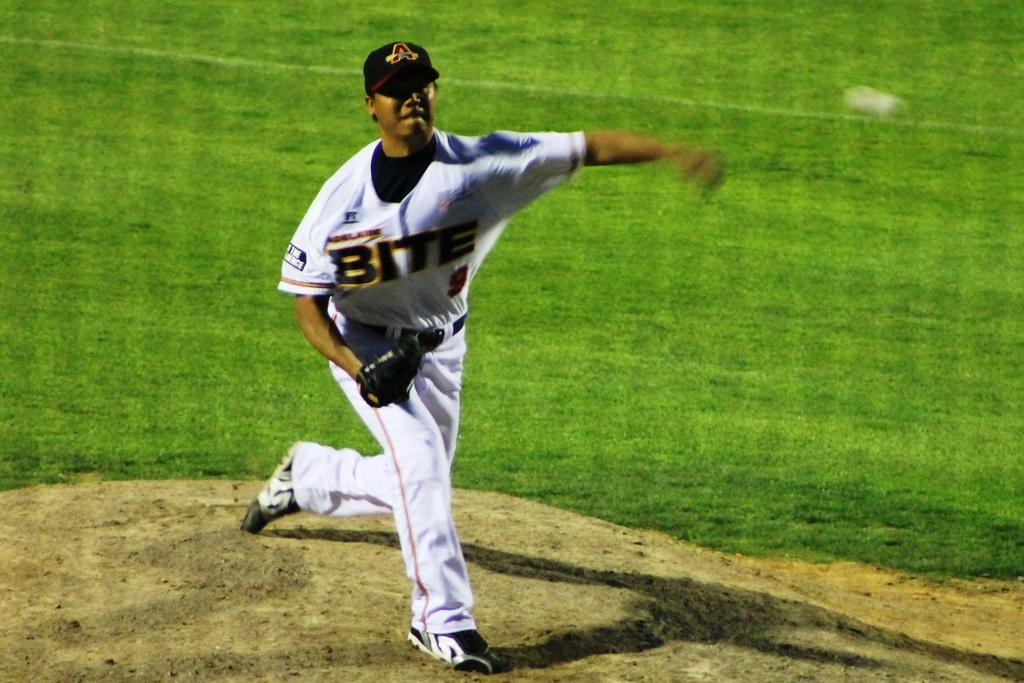<image>
Offer a succinct explanation of the picture presented. An Atlanta Braves baseball player throws a pitch. 